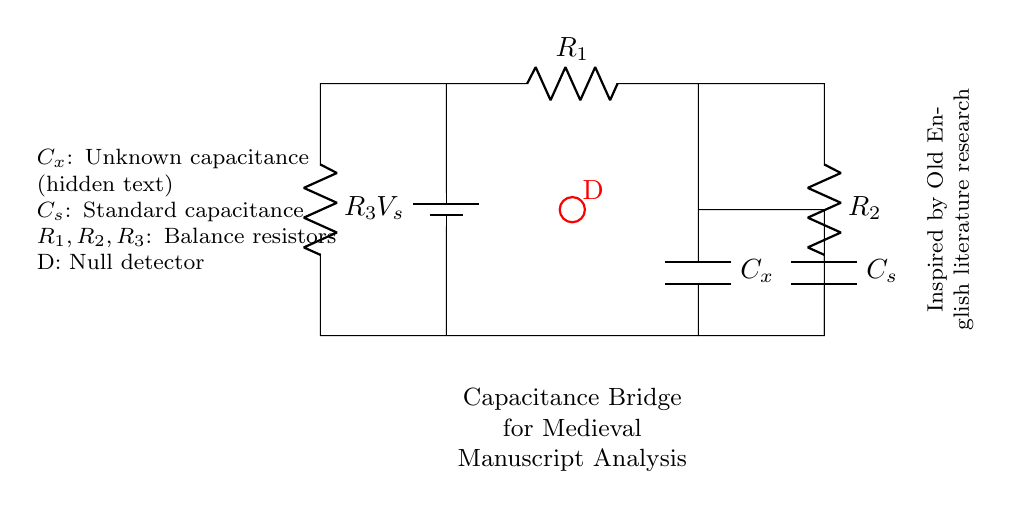What is the type of the circuit shown? The circuit is a capacitance bridge commonly used for measurement purposes, particularly to compare an unknown capacitance with a known standard.
Answer: capacitance bridge What does C_x represent in the circuit? C_x represents the unknown capacitance that we are trying to detect, such as hidden text in a manuscript.
Answer: unknown capacitance How many resistors are present in the circuit? There are three resistors in the circuit which are labeled R_1, R_2, and R_3, contributing to the balance in the circuit for the measurement.
Answer: three What is the purpose of the null detector D? The null detector is used to indicate when the bridge is balanced, meaning there is no difference in the voltage across its terminals, which helps in detecting the presence of the unknown capacitance.
Answer: indicate balance If the circuit is balanced, what happens to the voltage across the detector D? When the circuit is balanced, the voltage across the detector D is zero, which signifies that the unknown capacitance C_x equals the standard capacitance C_s in the system.
Answer: zero What role do the resistors R_1, R_2, and R_3 play in the circuit? The resistors R_1, R_2, and R_3 are used to create a balanced condition in the bridge circuit, allowing for the precise measurement of the unknown capacitance when the ratios are equal.
Answer: create balance What is C_s in the circuit? C_s is the standard capacitance used for comparison to the unknown capacitance C_x in the balance condition of the bridge circuit.
Answer: standard capacitance 